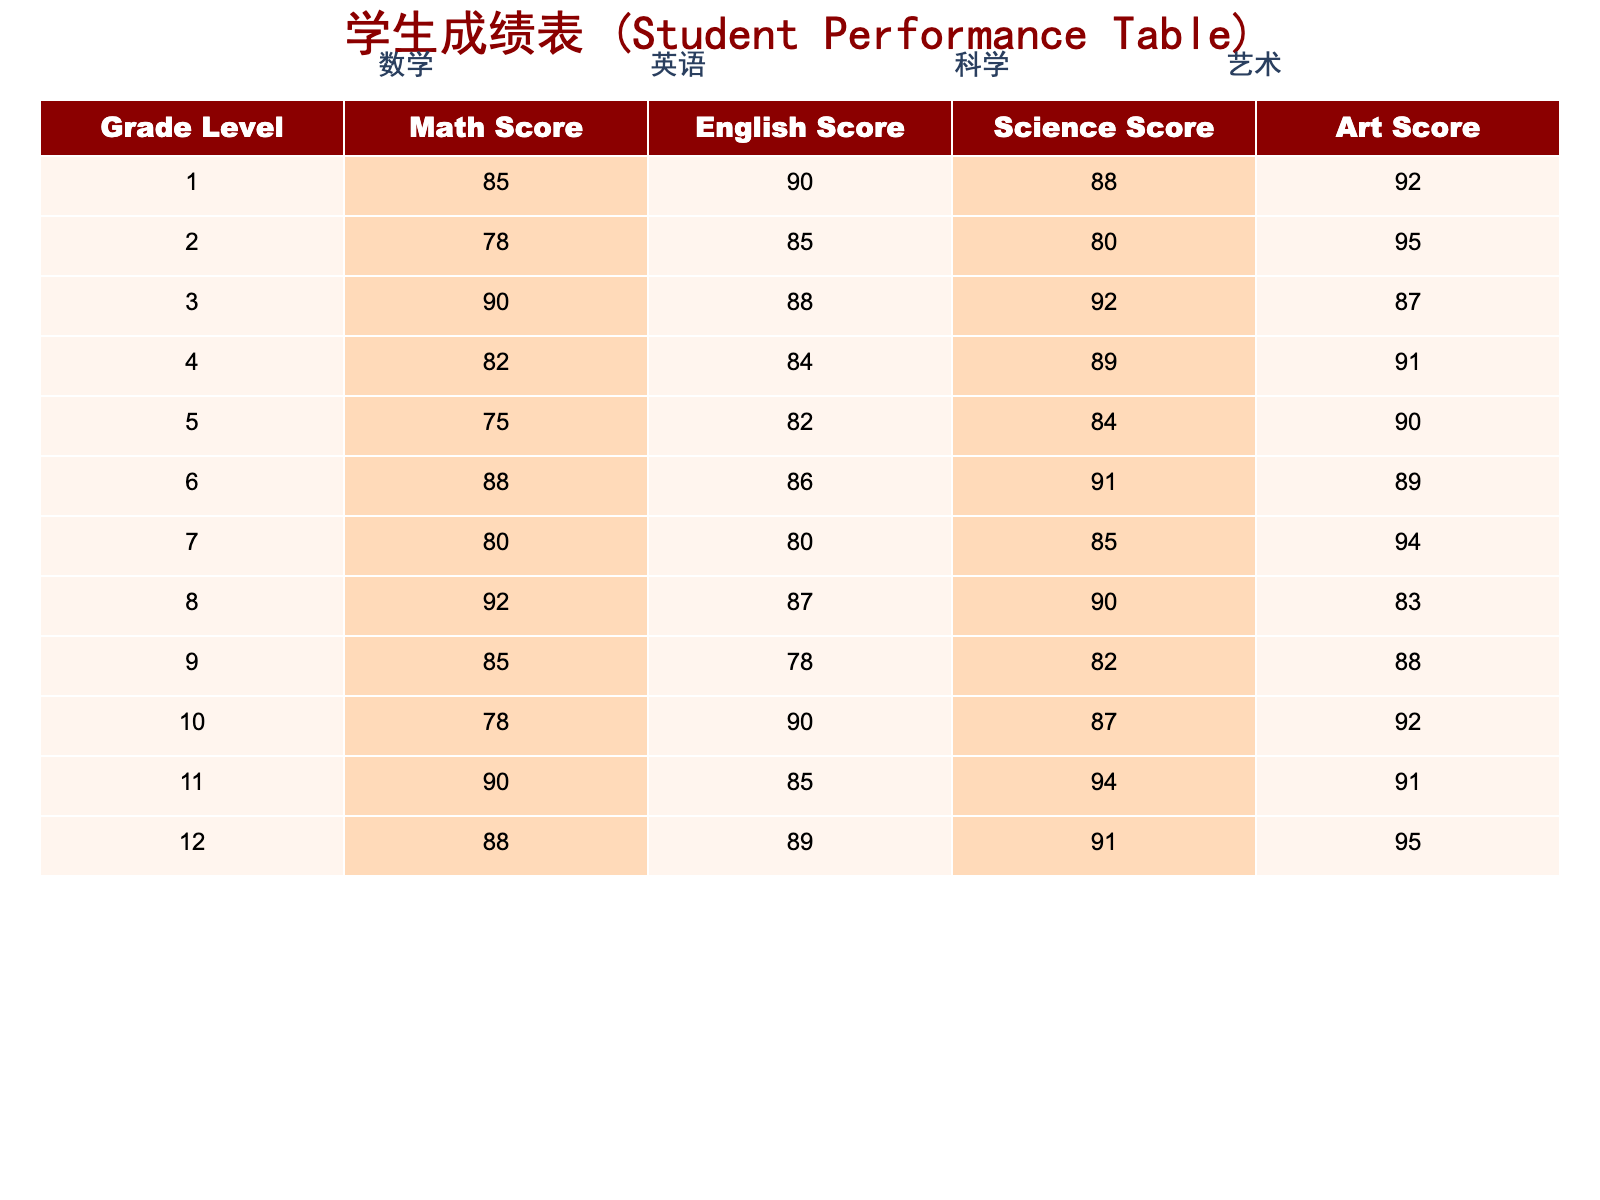What is the highest Math score achieved by 12th-grade students? Looking at the "Math Score" column under the row for "Grade Level" 12, the score is 88. This is the highest Math score for that grade level.
Answer: 88 What is the average English score for students in Grade Level 5 and Grade Level 6? The English scores for Grade Level 5 and 6 are 82 and 86 respectively. To find the average, sum these two scores: 82 + 86 = 168, and then divide by 2, which gives 168 / 2 = 84.
Answer: 84 Is it true that all students in Grade Level 1 scored above 85 in all subjects? Checking the scores for Grade Level 1 shows the following: Math 85, English 90, Science 88, and Art 92. Therefore, all scores are indeed above 85.
Answer: Yes What subject did 10th-grade students score the highest in? For the 10th grade, the scores are Math 78, English 90, Science 87, and Art 92. Among these scores, 92 in Art is the highest.
Answer: Art Which grade level has the lowest total score across all subjects? First, we sum the scores for each grade level: Grade 1: 85+90+88+92=355, Grade 2: 78+85+80+95=338, Grade 3: 90+88+92+87=357, Grade 4: 82+84+89+91=346, Grade 5: 75+82+84+90=331, Grade 6: 88+86+91+89=354, Grade 7: 80+80+85+94=339, Grade 8: 92+87+90+83=352, Grade 9: 85+78+82+88=333, Grade 10: 78+90+87+92=347, Grade 11: 90+85+94+91=360, Grade 12: 88+89+91+95=363. The lowest total score is for Grade 5 with a total of 331.
Answer: Grade Level 5 How many subjects scored an average of 90 or above for Grade Level 2? The scores for Grade Level 2 are Math 78, English 85, Science 80, and Art 95. Checking the averages: Math (78<90), English (85<90), Science (80<90), Art (95>=90). Only Art scores 90 or above, so just one subject meets the criteria.
Answer: 1 